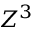Convert formula to latex. <formula><loc_0><loc_0><loc_500><loc_500>Z ^ { 3 }</formula> 